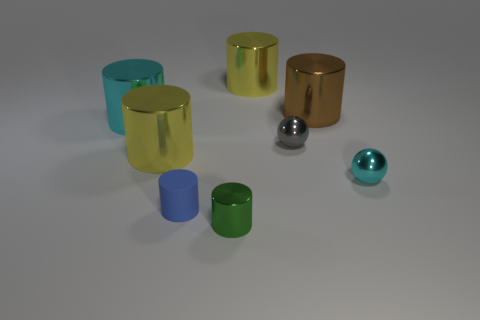Add 1 cyan metallic spheres. How many objects exist? 9 Subtract all small blue matte cylinders. How many cylinders are left? 5 Subtract all cyan spheres. How many spheres are left? 1 Subtract all cylinders. How many objects are left? 2 Subtract all gray cylinders. How many green spheres are left? 0 Subtract all small red rubber cylinders. Subtract all big cyan shiny cylinders. How many objects are left? 7 Add 4 cyan shiny spheres. How many cyan shiny spheres are left? 5 Add 5 cyan things. How many cyan things exist? 7 Subtract 0 red cylinders. How many objects are left? 8 Subtract 1 spheres. How many spheres are left? 1 